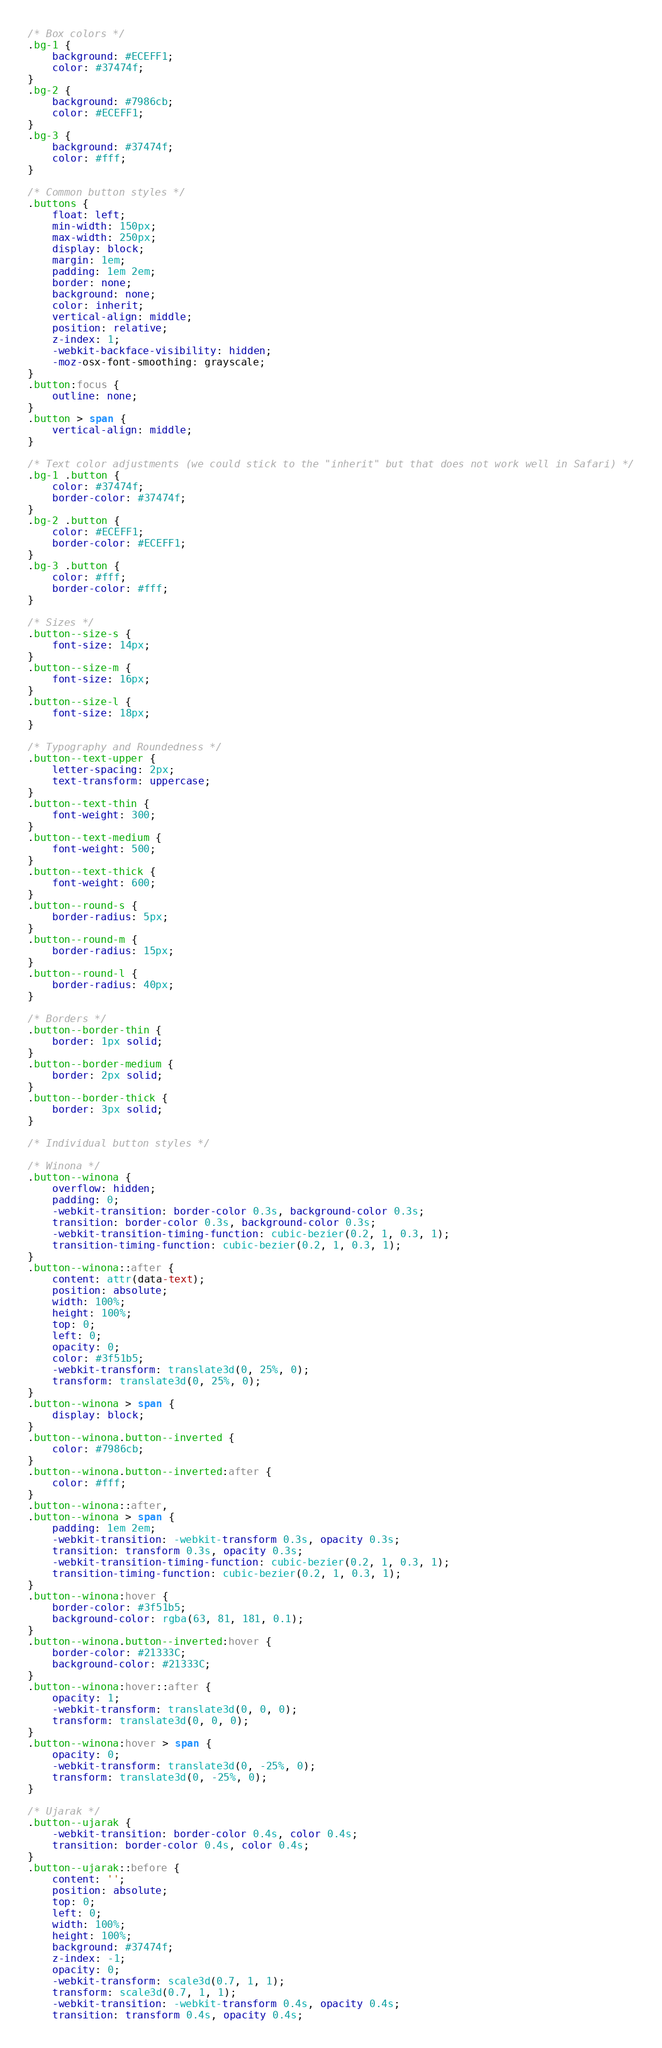<code> <loc_0><loc_0><loc_500><loc_500><_CSS_>/* Box colors */
.bg-1 {
	background: #ECEFF1;
	color: #37474f;
}
.bg-2 {
	background: #7986cb;
	color: #ECEFF1;
}
.bg-3 {
	background: #37474f;
	color: #fff;
}

/* Common button styles */
.buttons {
	float: left;
	min-width: 150px;
	max-width: 250px;
	display: block;
	margin: 1em;
	padding: 1em 2em;
	border: none;
	background: none;
	color: inherit;
	vertical-align: middle;
	position: relative;
	z-index: 1;
	-webkit-backface-visibility: hidden;
	-moz-osx-font-smoothing: grayscale;
}
.button:focus {
	outline: none;
}
.button > span {
	vertical-align: middle;
}

/* Text color adjustments (we could stick to the "inherit" but that does not work well in Safari) */
.bg-1 .button {
	color: #37474f;
	border-color: #37474f;
}
.bg-2 .button {
	color: #ECEFF1;
	border-color: #ECEFF1;
}
.bg-3 .button {
	color: #fff;
	border-color: #fff;
}

/* Sizes */
.button--size-s {
	font-size: 14px;
}
.button--size-m {
	font-size: 16px;
}
.button--size-l {
	font-size: 18px;
}

/* Typography and Roundedness */
.button--text-upper {
	letter-spacing: 2px;
	text-transform: uppercase;
}
.button--text-thin {
	font-weight: 300;
}
.button--text-medium {
	font-weight: 500;
}
.button--text-thick {
	font-weight: 600;
}
.button--round-s {
	border-radius: 5px;
}
.button--round-m {
	border-radius: 15px;
}
.button--round-l {
	border-radius: 40px;
}

/* Borders */
.button--border-thin {
	border: 1px solid;
}
.button--border-medium {
	border: 2px solid;
}
.button--border-thick {
	border: 3px solid;
}

/* Individual button styles */

/* Winona */
.button--winona {
	overflow: hidden;
	padding: 0;
	-webkit-transition: border-color 0.3s, background-color 0.3s;
	transition: border-color 0.3s, background-color 0.3s;
	-webkit-transition-timing-function: cubic-bezier(0.2, 1, 0.3, 1);
	transition-timing-function: cubic-bezier(0.2, 1, 0.3, 1);
}
.button--winona::after {
	content: attr(data-text);
	position: absolute;
	width: 100%;
	height: 100%;
	top: 0;
	left: 0;
	opacity: 0;
	color: #3f51b5;
	-webkit-transform: translate3d(0, 25%, 0);
	transform: translate3d(0, 25%, 0);
}
.button--winona > span {
	display: block;
}
.button--winona.button--inverted {
	color: #7986cb;
}
.button--winona.button--inverted:after {
	color: #fff;
}
.button--winona::after,
.button--winona > span {
	padding: 1em 2em;
	-webkit-transition: -webkit-transform 0.3s, opacity 0.3s;
	transition: transform 0.3s, opacity 0.3s;
	-webkit-transition-timing-function: cubic-bezier(0.2, 1, 0.3, 1);
	transition-timing-function: cubic-bezier(0.2, 1, 0.3, 1);
}
.button--winona:hover {
	border-color: #3f51b5;
	background-color: rgba(63, 81, 181, 0.1);
}
.button--winona.button--inverted:hover {
	border-color: #21333C;
	background-color: #21333C;
}
.button--winona:hover::after {
	opacity: 1;
	-webkit-transform: translate3d(0, 0, 0);
	transform: translate3d(0, 0, 0);
}
.button--winona:hover > span {
	opacity: 0;
	-webkit-transform: translate3d(0, -25%, 0);
	transform: translate3d(0, -25%, 0);
}

/* Ujarak */
.button--ujarak {
	-webkit-transition: border-color 0.4s, color 0.4s;
	transition: border-color 0.4s, color 0.4s;
}
.button--ujarak::before {
	content: '';
	position: absolute;
	top: 0;
	left: 0;
	width: 100%;
	height: 100%;
	background: #37474f;
	z-index: -1;
	opacity: 0;
	-webkit-transform: scale3d(0.7, 1, 1);
	transform: scale3d(0.7, 1, 1);
	-webkit-transition: -webkit-transform 0.4s, opacity 0.4s;
	transition: transform 0.4s, opacity 0.4s;</code> 